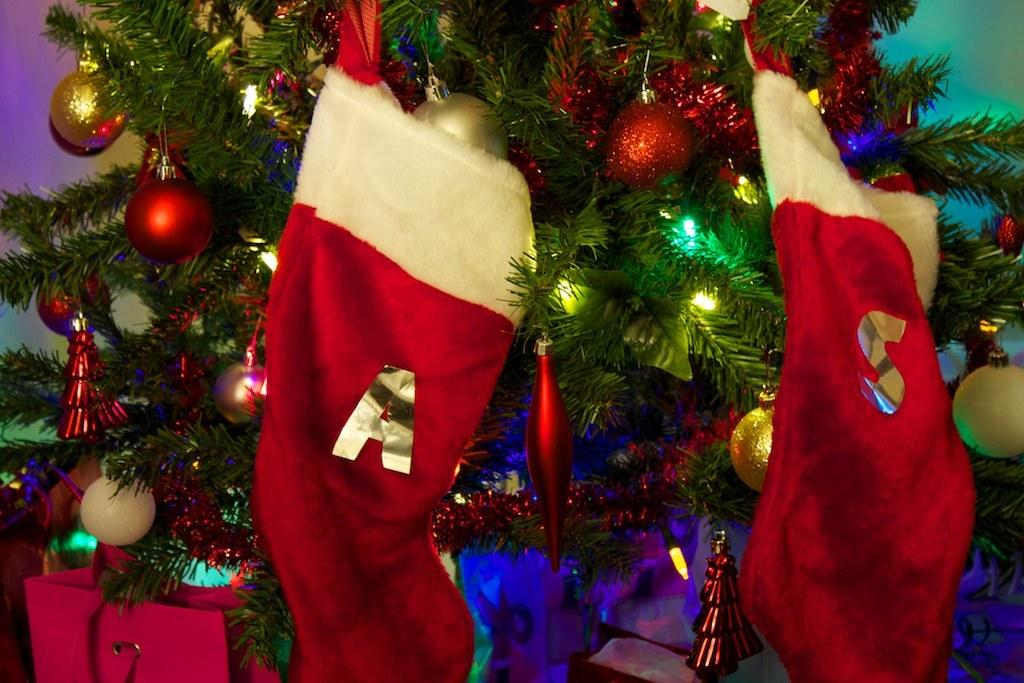What type of tree is in the image? There is a colorful Christmas tree in the image. What decorations are on the Christmas tree? The Christmas tree has lights, balls, and caps on it. What else can be seen in the image besides the Christmas tree? There is a bag visible in the image. What type of relation does the market have with the Christmas tree in the image? There is no mention of a market in the image, so it is not possible to determine any relation between the market and the Christmas tree. 